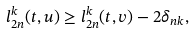Convert formula to latex. <formula><loc_0><loc_0><loc_500><loc_500>l _ { 2 n } ^ { k } ( t , u ) \geq l _ { 2 n } ^ { k } ( t , v ) - 2 \delta _ { n k } ,</formula> 